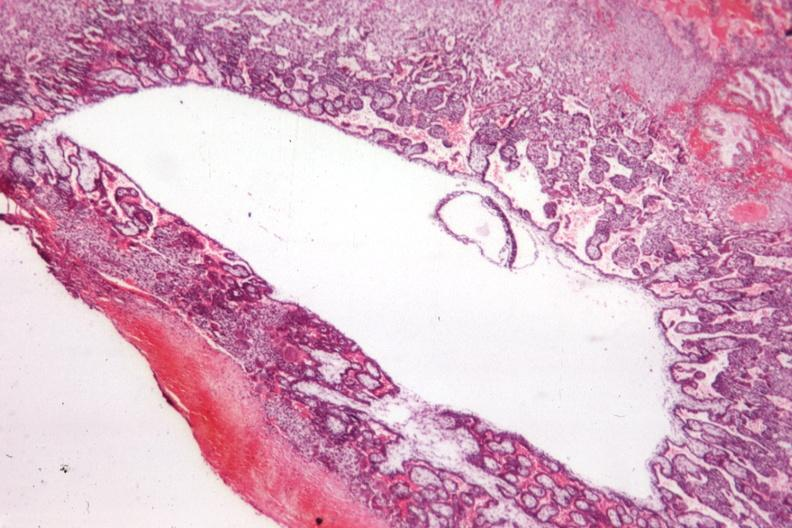s endometritis postpartum present?
Answer the question using a single word or phrase. No 